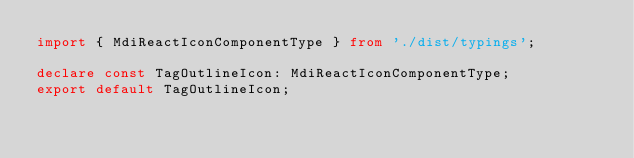<code> <loc_0><loc_0><loc_500><loc_500><_TypeScript_>import { MdiReactIconComponentType } from './dist/typings';

declare const TagOutlineIcon: MdiReactIconComponentType;
export default TagOutlineIcon;
</code> 